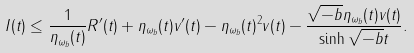<formula> <loc_0><loc_0><loc_500><loc_500>I ( t ) \leq \frac { 1 } { \eta _ { \omega _ { b } } ( t ) } R ^ { \prime } ( t ) + \eta _ { \omega _ { b } } ( t ) v ^ { \prime } ( t ) - \eta _ { \omega _ { b } } ( t ) ^ { 2 } v ( t ) - \frac { \sqrt { - b } \eta _ { \omega _ { b } } ( t ) v ( t ) } { \sinh \sqrt { - b } t } .</formula> 